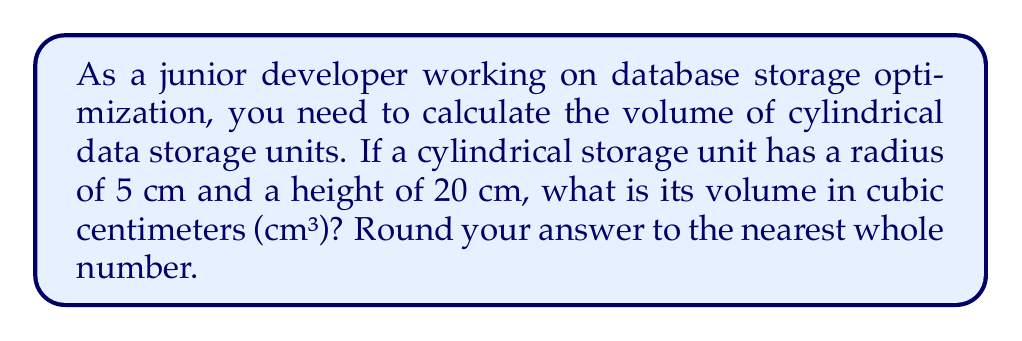Could you help me with this problem? To solve this problem, we'll use the formula for the volume of a cylinder:

$$V = \pi r^2 h$$

Where:
$V$ = volume
$\pi$ = pi (approximately 3.14159)
$r$ = radius of the base
$h$ = height of the cylinder

Given:
$r = 5$ cm
$h = 20$ cm

Let's substitute these values into the formula:

$$V = \pi (5 \text{ cm})^2 (20 \text{ cm})$$

Now, let's calculate step by step:

1. Calculate $r^2$:
   $5^2 = 25$

2. Multiply by $\pi$:
   $\pi \cdot 25 \approx 78.53982$

3. Multiply by the height:
   $78.53982 \cdot 20 = 1570.7964$ cm³

4. Round to the nearest whole number:
   $1570.7964$ rounds to $1571$ cm³

This calculation helps in estimating the storage capacity of cylindrical units, which is crucial for database storage optimization.
Answer: $1571$ cm³ 